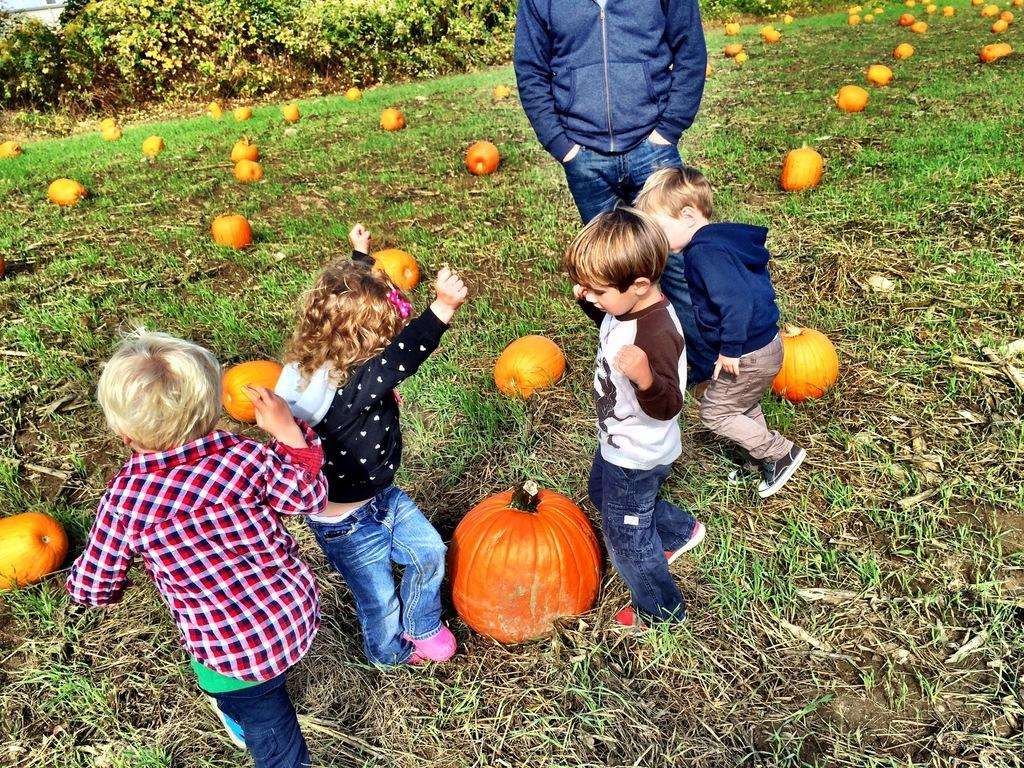What can be seen in the image? There are kids in the image. Can you describe the background of the image? There is a man standing in the background of the image, and there are plants visible as well. What objects are on the floor in the image? There are pumpkins on the floor in the image. What type of straw is being used by the kids in the image? There is no straw present in the image. Can you see an airplane in the image? No, there is no airplane visible in the image. 